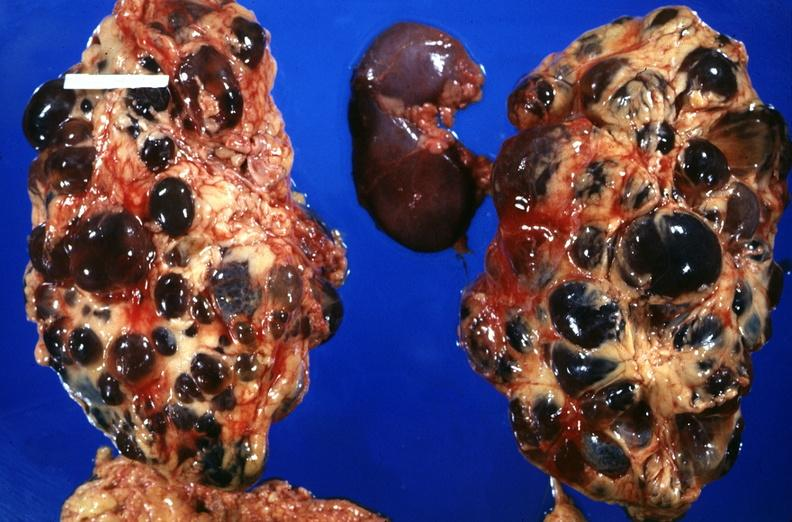what does this image show?
Answer the question using a single word or phrase. Kidney 